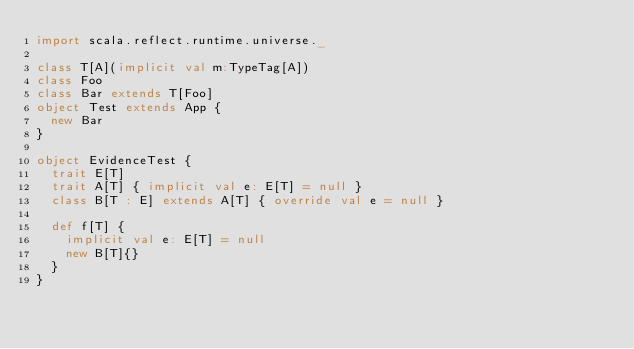Convert code to text. <code><loc_0><loc_0><loc_500><loc_500><_Scala_>import scala.reflect.runtime.universe._

class T[A](implicit val m:TypeTag[A])
class Foo
class Bar extends T[Foo]
object Test extends App {
  new Bar
}

object EvidenceTest {
  trait E[T]
  trait A[T] { implicit val e: E[T] = null }
  class B[T : E] extends A[T] { override val e = null }

  def f[T] {
    implicit val e: E[T] = null
    new B[T]{}
  }
}</code> 